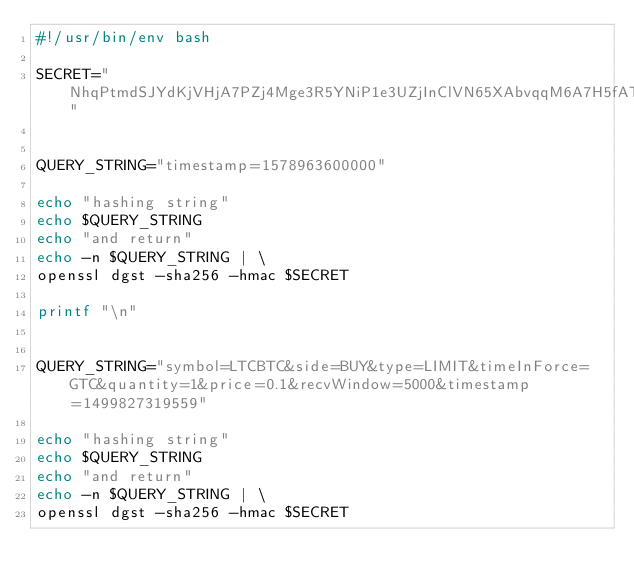Convert code to text. <code><loc_0><loc_0><loc_500><loc_500><_Bash_>#!/usr/bin/env bash

SECRET="NhqPtmdSJYdKjVHjA7PZj4Mge3R5YNiP1e3UZjInClVN65XAbvqqM6A7H5fATj0j"


QUERY_STRING="timestamp=1578963600000"

echo "hashing string"
echo $QUERY_STRING
echo "and return"
echo -n $QUERY_STRING | \
openssl dgst -sha256 -hmac $SECRET

printf "\n"


QUERY_STRING="symbol=LTCBTC&side=BUY&type=LIMIT&timeInForce=GTC&quantity=1&price=0.1&recvWindow=5000&timestamp=1499827319559"

echo "hashing string"
echo $QUERY_STRING
echo "and return"
echo -n $QUERY_STRING | \
openssl dgst -sha256 -hmac $SECRET
</code> 